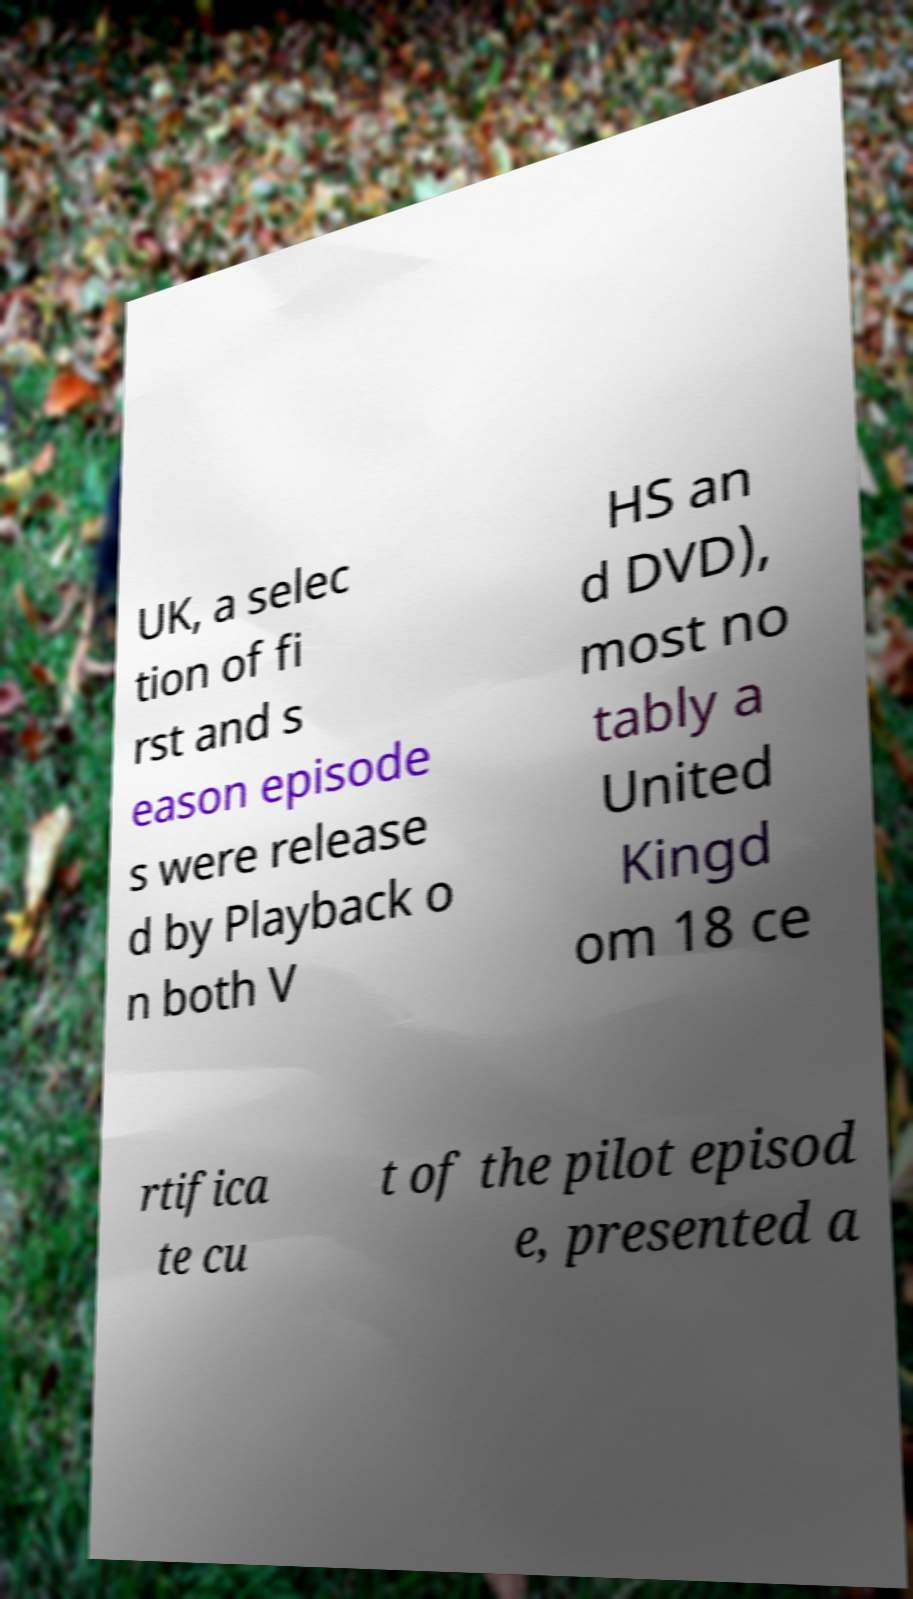I need the written content from this picture converted into text. Can you do that? UK, a selec tion of fi rst and s eason episode s were release d by Playback o n both V HS an d DVD), most no tably a United Kingd om 18 ce rtifica te cu t of the pilot episod e, presented a 